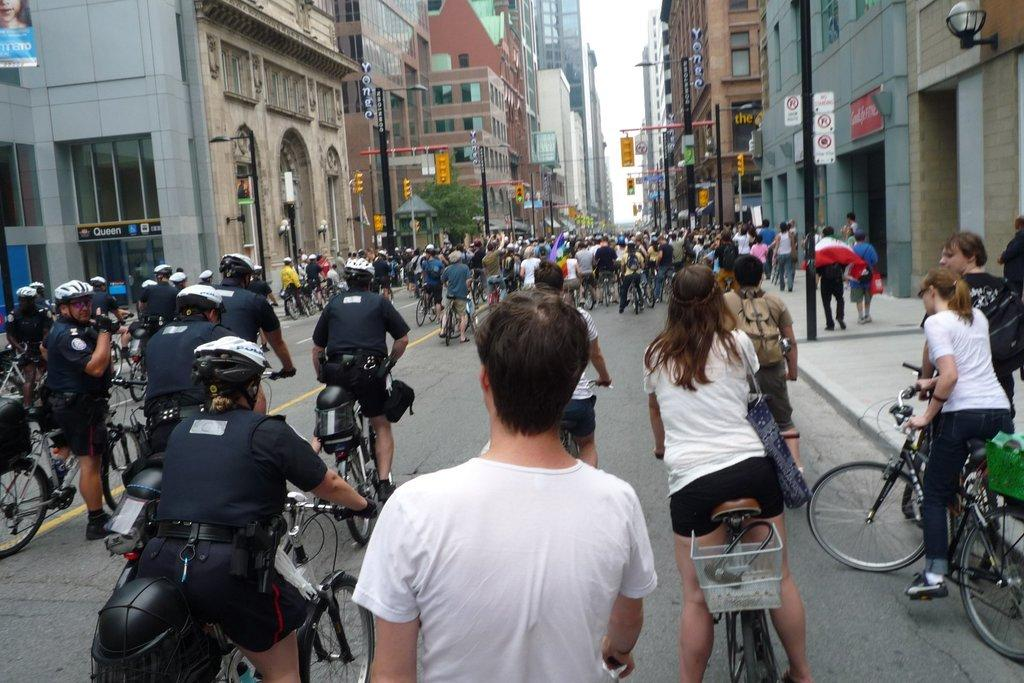What structures are visible in the image? There are buildings in the image. What activity are people engaged in on the road in the image? People are riding bicycles on the road in the image. Where is the hall located in the image? There is no hall present in the image. What emotion is being expressed by the sponge in the image? There is no sponge present in the image, and therefore no emotion can be attributed to it. 